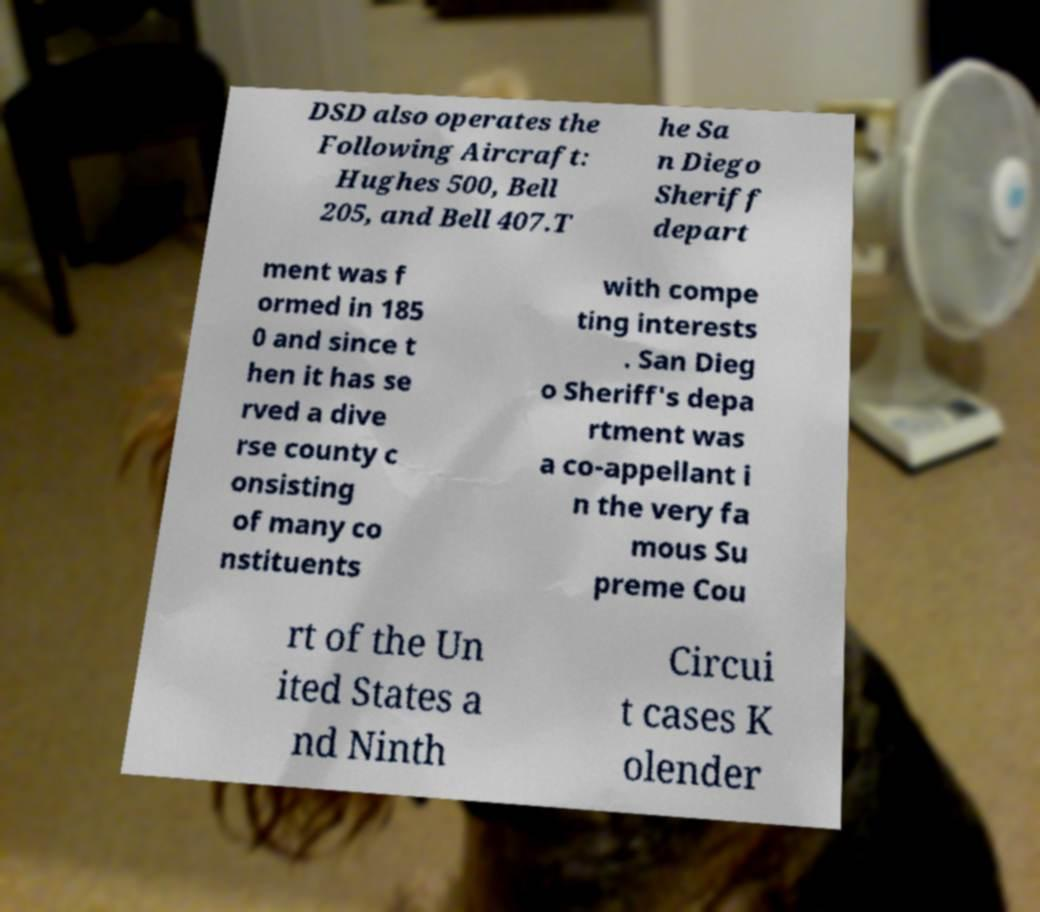For documentation purposes, I need the text within this image transcribed. Could you provide that? DSD also operates the Following Aircraft: Hughes 500, Bell 205, and Bell 407.T he Sa n Diego Sheriff depart ment was f ormed in 185 0 and since t hen it has se rved a dive rse county c onsisting of many co nstituents with compe ting interests . San Dieg o Sheriff's depa rtment was a co-appellant i n the very fa mous Su preme Cou rt of the Un ited States a nd Ninth Circui t cases K olender 